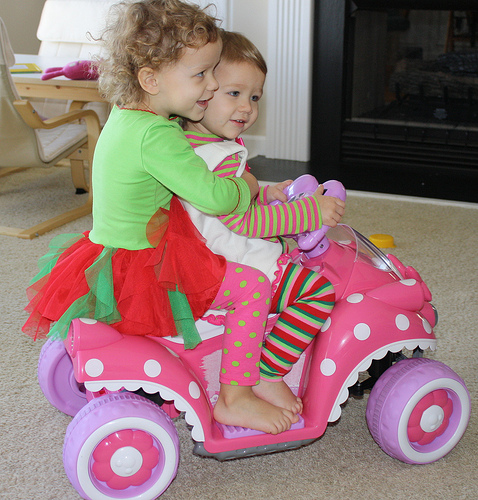<image>
Is the toy car under the girl? Yes. The toy car is positioned underneath the girl, with the girl above it in the vertical space. Where is the kids in relation to the car? Is it next to the car? No. The kids is not positioned next to the car. They are located in different areas of the scene. 